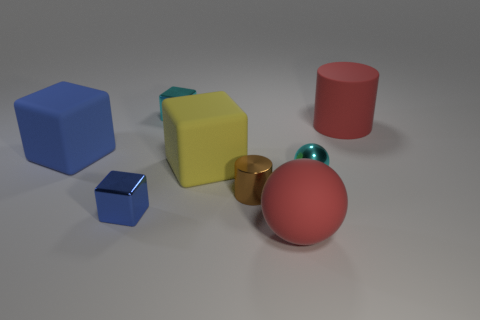Subtract all cyan metallic cubes. How many cubes are left? 3 Subtract all gray spheres. How many blue cubes are left? 2 Add 2 small metal things. How many objects exist? 10 Subtract all red spheres. How many spheres are left? 1 Subtract 2 cylinders. How many cylinders are left? 0 Subtract 1 cyan cubes. How many objects are left? 7 Subtract all balls. How many objects are left? 6 Subtract all green cylinders. Subtract all purple balls. How many cylinders are left? 2 Subtract all big matte things. Subtract all brown metal cylinders. How many objects are left? 3 Add 6 shiny blocks. How many shiny blocks are left? 8 